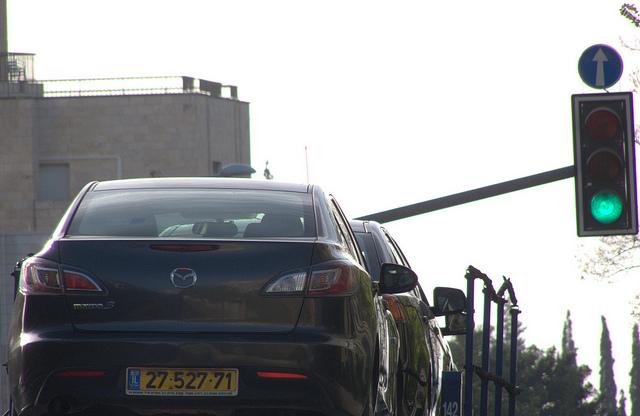Does the car have a US license plate?
Short answer required. No. Should the car stop or go?
Answer briefly. Go. Are the trees in the distance oblong, or conic?
Quick response, please. Conic. 